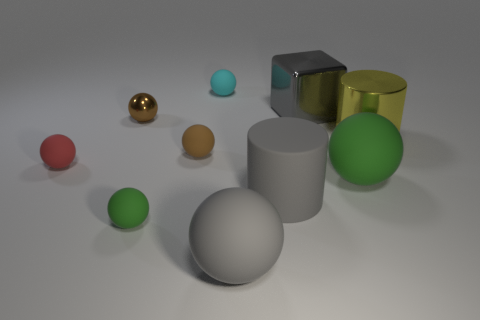Subtract 2 spheres. How many spheres are left? 5 Subtract all green spheres. How many spheres are left? 5 Subtract all gray rubber spheres. How many spheres are left? 6 Subtract all yellow spheres. Subtract all red cubes. How many spheres are left? 7 Subtract all cubes. How many objects are left? 9 Subtract 0 cyan cylinders. How many objects are left? 10 Subtract all big brown objects. Subtract all large gray shiny cubes. How many objects are left? 9 Add 7 cylinders. How many cylinders are left? 9 Add 2 brown metallic balls. How many brown metallic balls exist? 3 